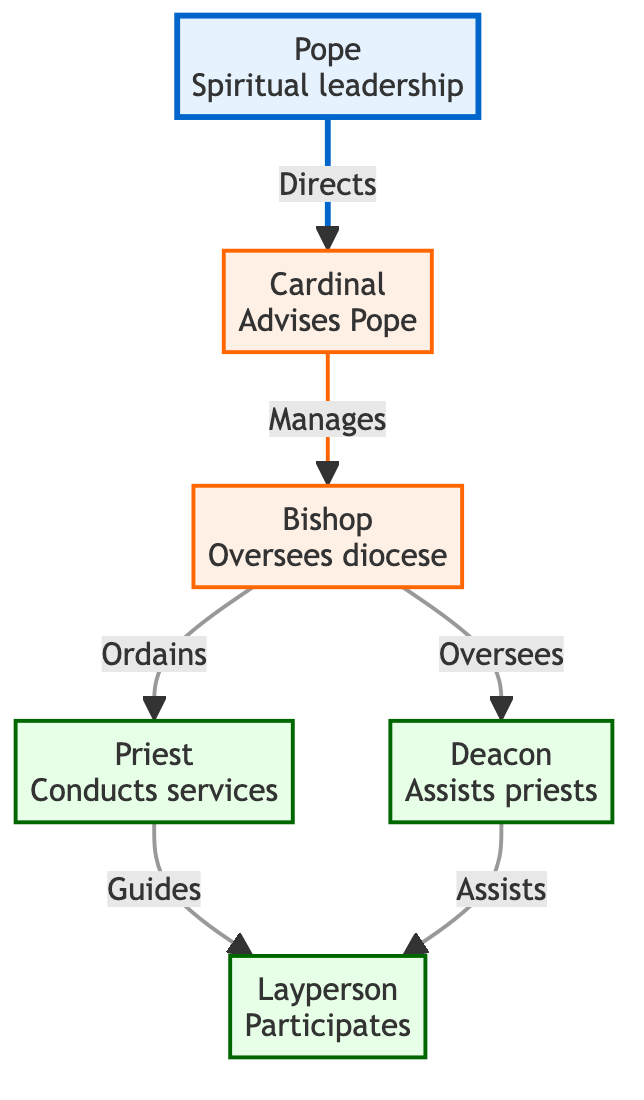What is the highest position in the hierarchy? The diagram shows that the highest position, represented by node 1, is the Pope. There are no other nodes above it, indicating its top position in the hierarchy.
Answer: Pope How many roles are illustrated in the diagram? By counting the nodes listed in the diagram, we find a total of 6 distinct roles, which include the Pope, Cardinal, Bishop, Priest, Deacon, and Layperson.
Answer: 6 Who does the Cardinal directly advise? According to the diagram, the Cardinal, represented by node 2, has a direct link to the Pope, suggesting that the Cardinal gives advice specifically to the Pope.
Answer: Pope Which role manages local parishes? The Bishop, represented by node 3, is indicated to manage local parishes, as it oversees a diocese and holds the responsibility for those local churches.
Answer: Bishop What is the primary duty of the Deacon? The Deacon's primary responsibility, as noted in the diagram, includes assisting priests in their services, which is provided in node 5's description.
Answer: Assists priests How many edges are there connecting the roles? By counting the connections or edges shown in the diagram, we observe there are 6 edges linking the various roles and responsibilities in the hierarchy.
Answer: 6 Which two roles have a guiding relationship in the diagram? The relationship is seen between the Priest (node 4) and the Layperson (node 6), where the Priest is indicated to guide the Layperson in church activities as described in the links.
Answer: Priest and Layperson What role is responsible for conducting religious services? The diagram specifies that the Priest (node 4) conducts religious services, which is one of their main responsibilities detailed in their description.
Answer: Priest Which role ordains priests? The Bishop, represented by node 3, is responsible for ordaining priests, as indicated in the flow from the Bishop to the Priest in the directed graph.
Answer: Bishop 